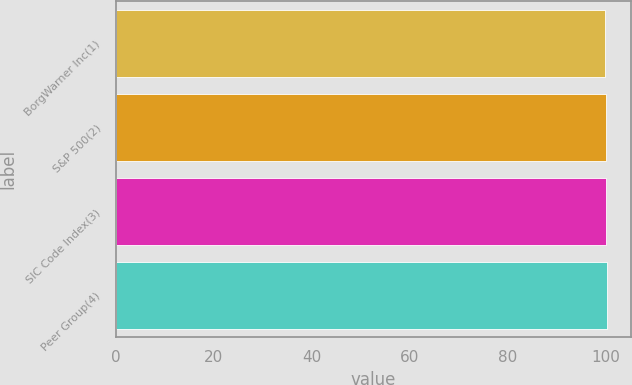Convert chart. <chart><loc_0><loc_0><loc_500><loc_500><bar_chart><fcel>BorgWarner Inc(1)<fcel>S&P 500(2)<fcel>SIC Code Index(3)<fcel>Peer Group(4)<nl><fcel>100<fcel>100.1<fcel>100.2<fcel>100.3<nl></chart> 